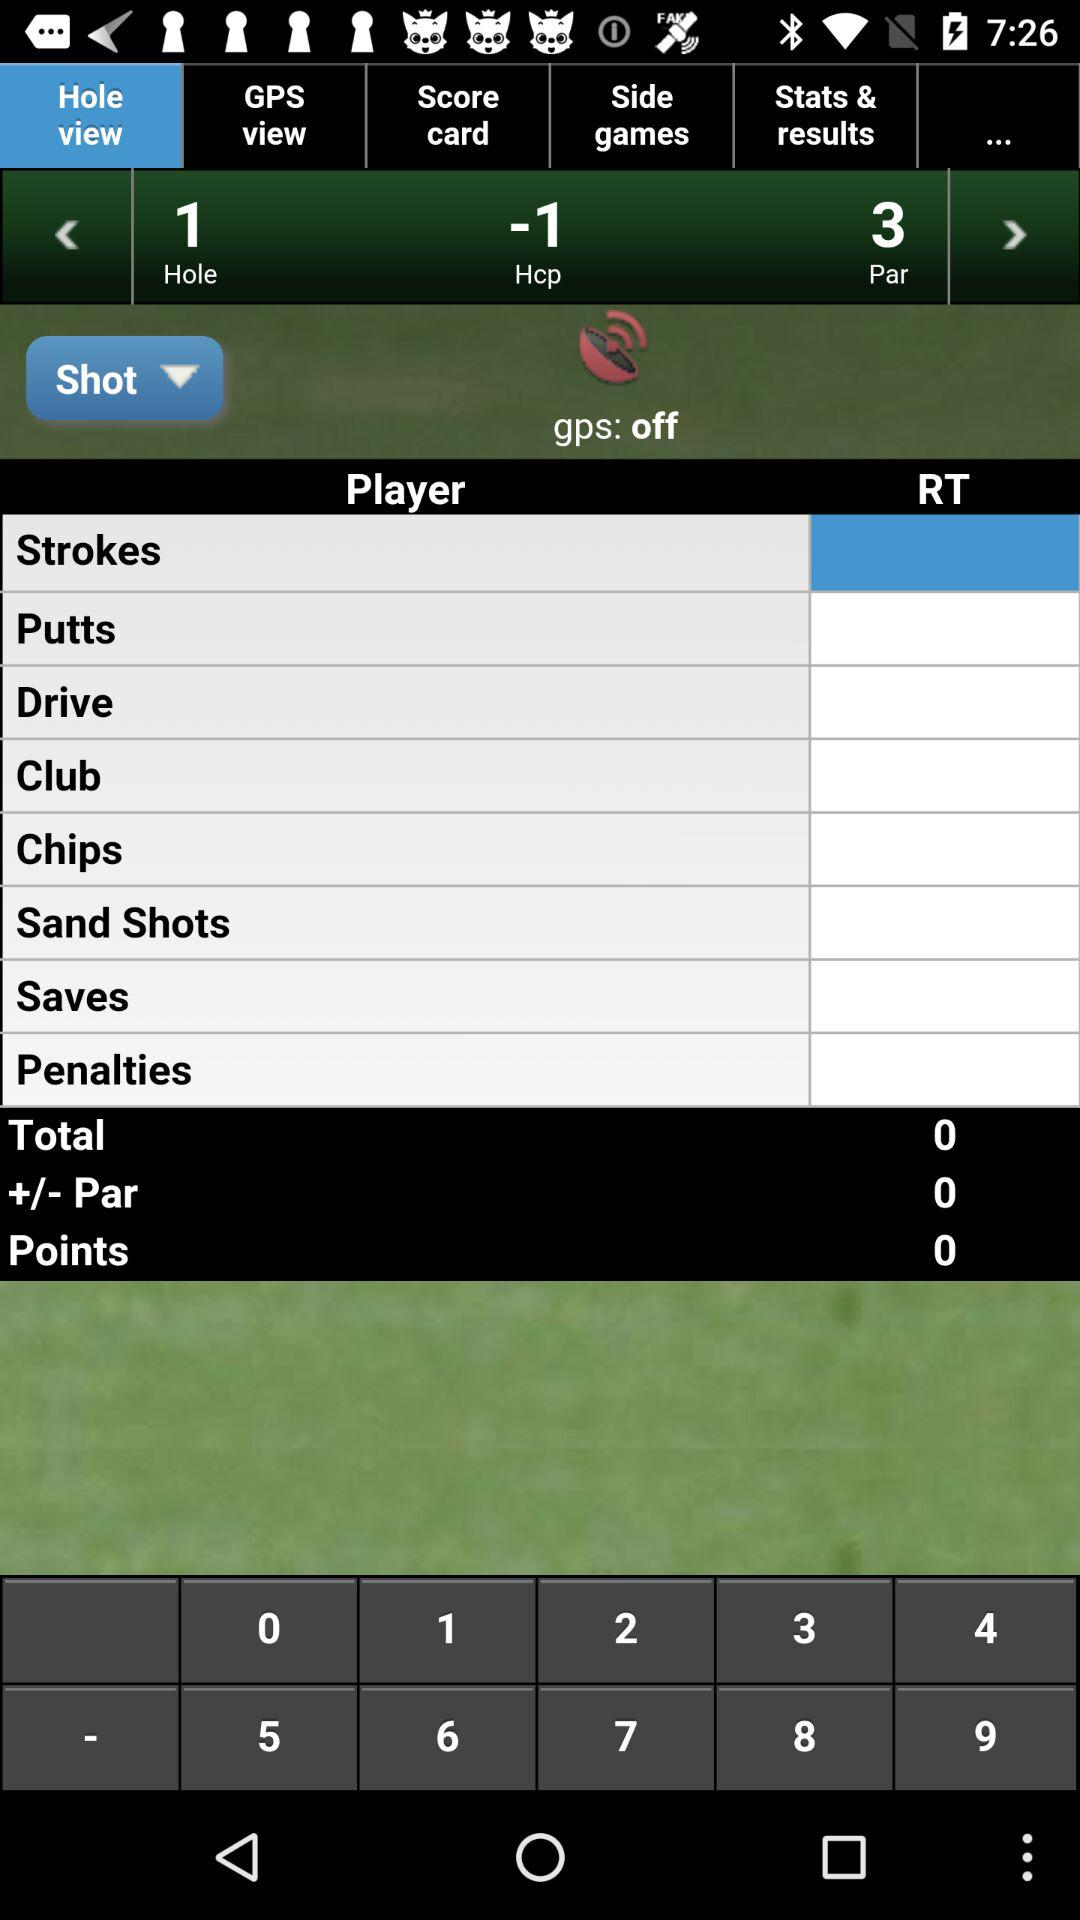What is the select RT?
When the provided information is insufficient, respond with <no answer>. <no answer> 